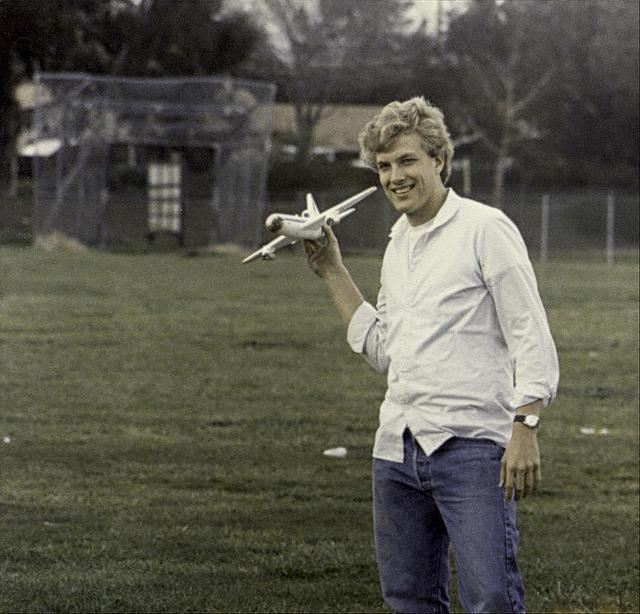How many people are in the photo?
Give a very brief answer. 1. 